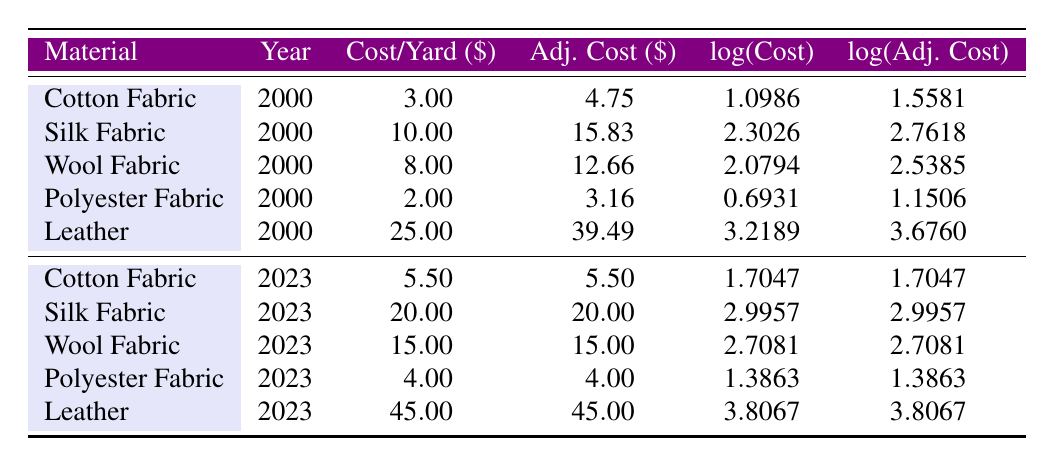What is the cost per yard of wool fabric in 2000? By looking at the table, we can see the row for wool fabric in the year 2000. The value for cost per yard in that row is 8.00.
Answer: 8.00 What is the adjusted cost of silk fabric in 2023? The table shows the row for silk fabric in the year 2023. The adjusted cost noted there is 20.00.
Answer: 20.00 Which fabric had the highest cost per yard in 2000? Looking at the cost per yard values for all fabrics listed in 2000, leather has the highest cost at 25.00.
Answer: Leather Is the adjusted cost of cotton fabric the same in 2000 and 2023? The table shows the adjusted cost for cotton fabric in 2000 is 4.75 and in 2023 is 5.50. Since these amounts are different, the answer is no.
Answer: No What is the difference in adjusted costs between leather fabric in 2023 and silk fabric in 2000? For leather in 2023, the adjusted cost is 45.00, and for silk in 2000, it is 15.83. The difference is 45.00 - 15.83 = 29.17.
Answer: 29.17 What is the average cost per yard of polyester fabric from both years? The costs for polyester are 2.00 in 2000 and 4.00 in 2023. We add them together: 2.00 + 4.00 = 6.00, then divide by 2 to find the average: 6.00 / 2 = 3.00.
Answer: 3.00 Which material saw the largest increase in its cost per yard from 2000 to 2023? By comparing the costs per yard from each year, leather has increased from 25.00 in 2000 to 45.00 in 2023, which is an increase of 20.00. This is larger than any other material's increase.
Answer: Leather Is the cost of cotton fabric in 2023 higher than that in 2000? In 2000, the cost was 3.00, and in 2023, it is 5.50. Since 5.50 is greater than 3.00, the answer is yes.
Answer: Yes What are the logarithmic values for the adjusted cost of wool fabric in both years? The logarithmic value for wool fabric's adjusted cost in 2000 is 2.5385, and in 2023 it is 2.7081. These values can be found directly in the respective rows of the table.
Answer: 2.5385 and 2.7081 